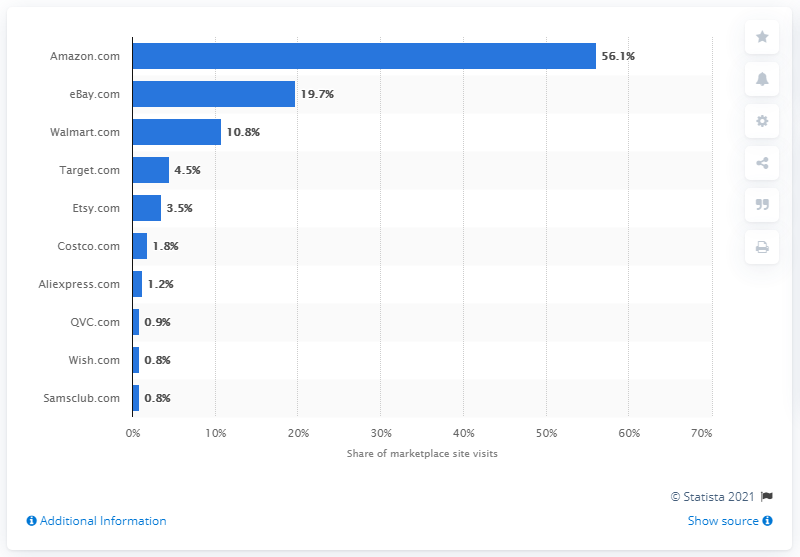Specify some key components in this picture. In the fourth quarter of 2018, Amazon accounted for approximately 56.1% of the total traffic. 